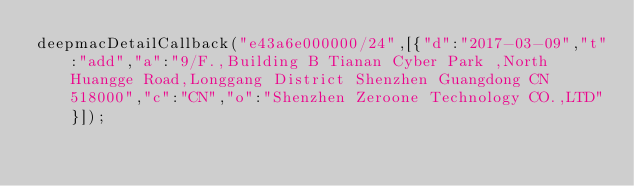Convert code to text. <code><loc_0><loc_0><loc_500><loc_500><_JavaScript_>deepmacDetailCallback("e43a6e000000/24",[{"d":"2017-03-09","t":"add","a":"9/F.,Building B Tianan Cyber Park ,North Huangge Road,Longgang District Shenzhen Guangdong CN 518000","c":"CN","o":"Shenzhen Zeroone Technology CO.,LTD"}]);
</code> 